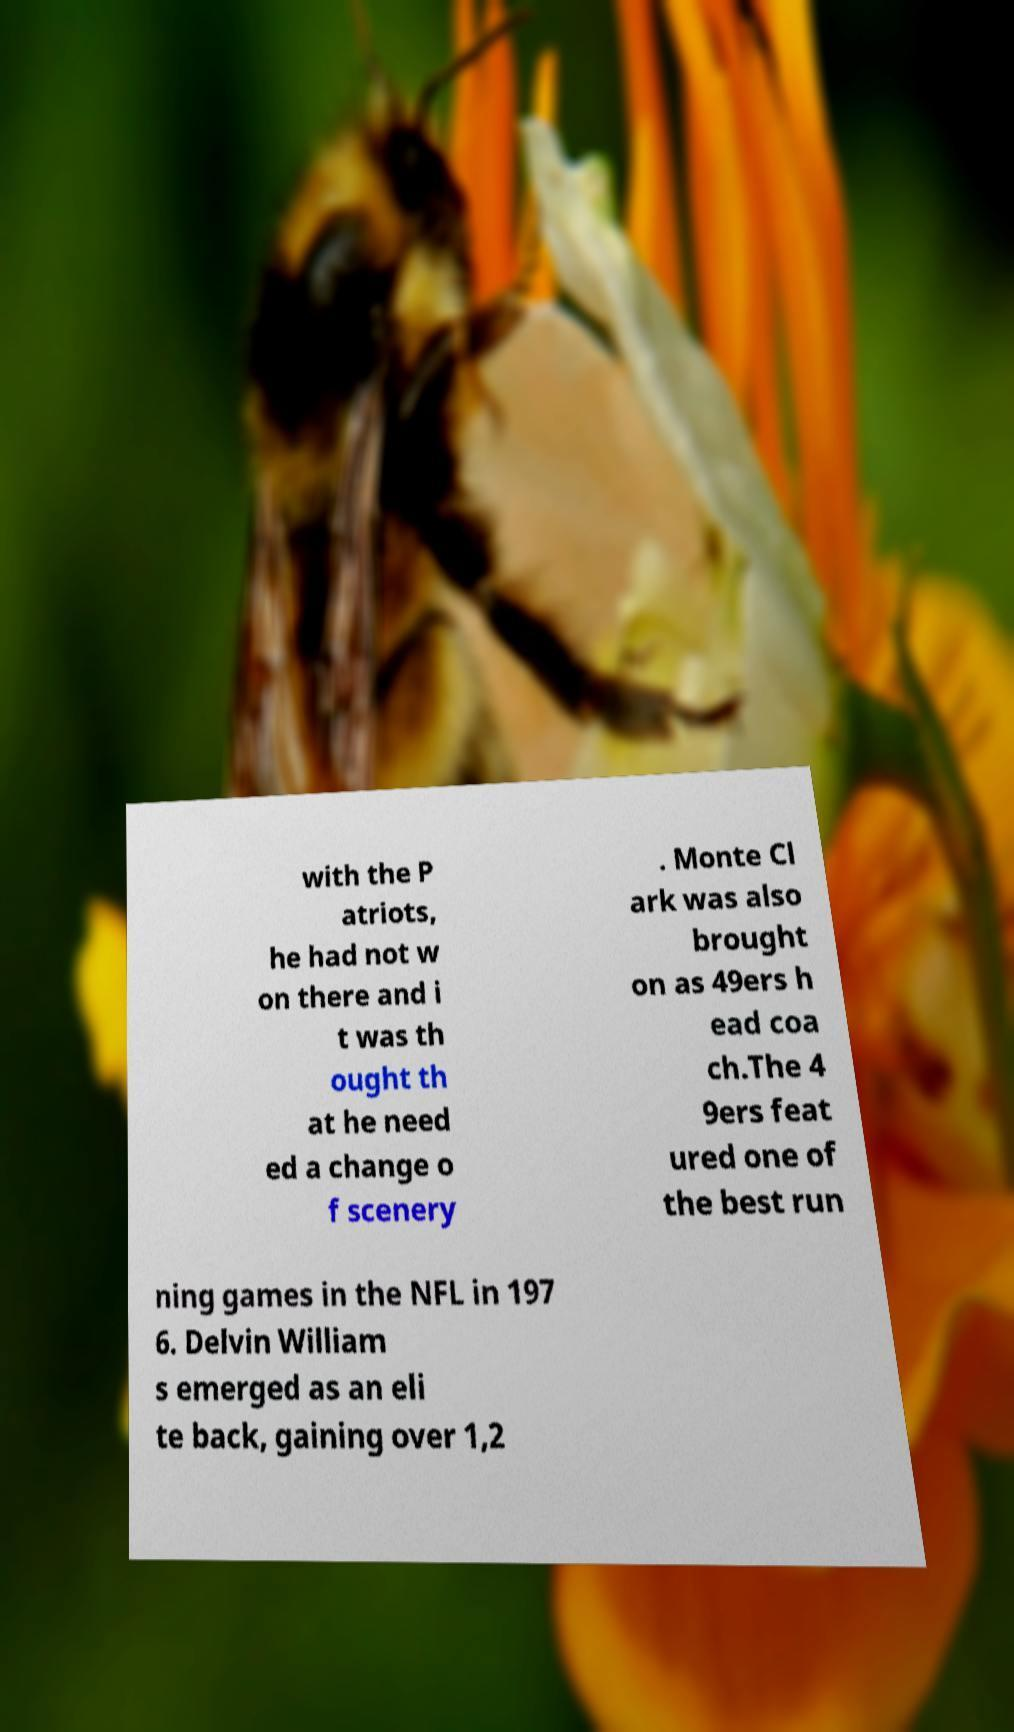Please identify and transcribe the text found in this image. with the P atriots, he had not w on there and i t was th ought th at he need ed a change o f scenery . Monte Cl ark was also brought on as 49ers h ead coa ch.The 4 9ers feat ured one of the best run ning games in the NFL in 197 6. Delvin William s emerged as an eli te back, gaining over 1,2 